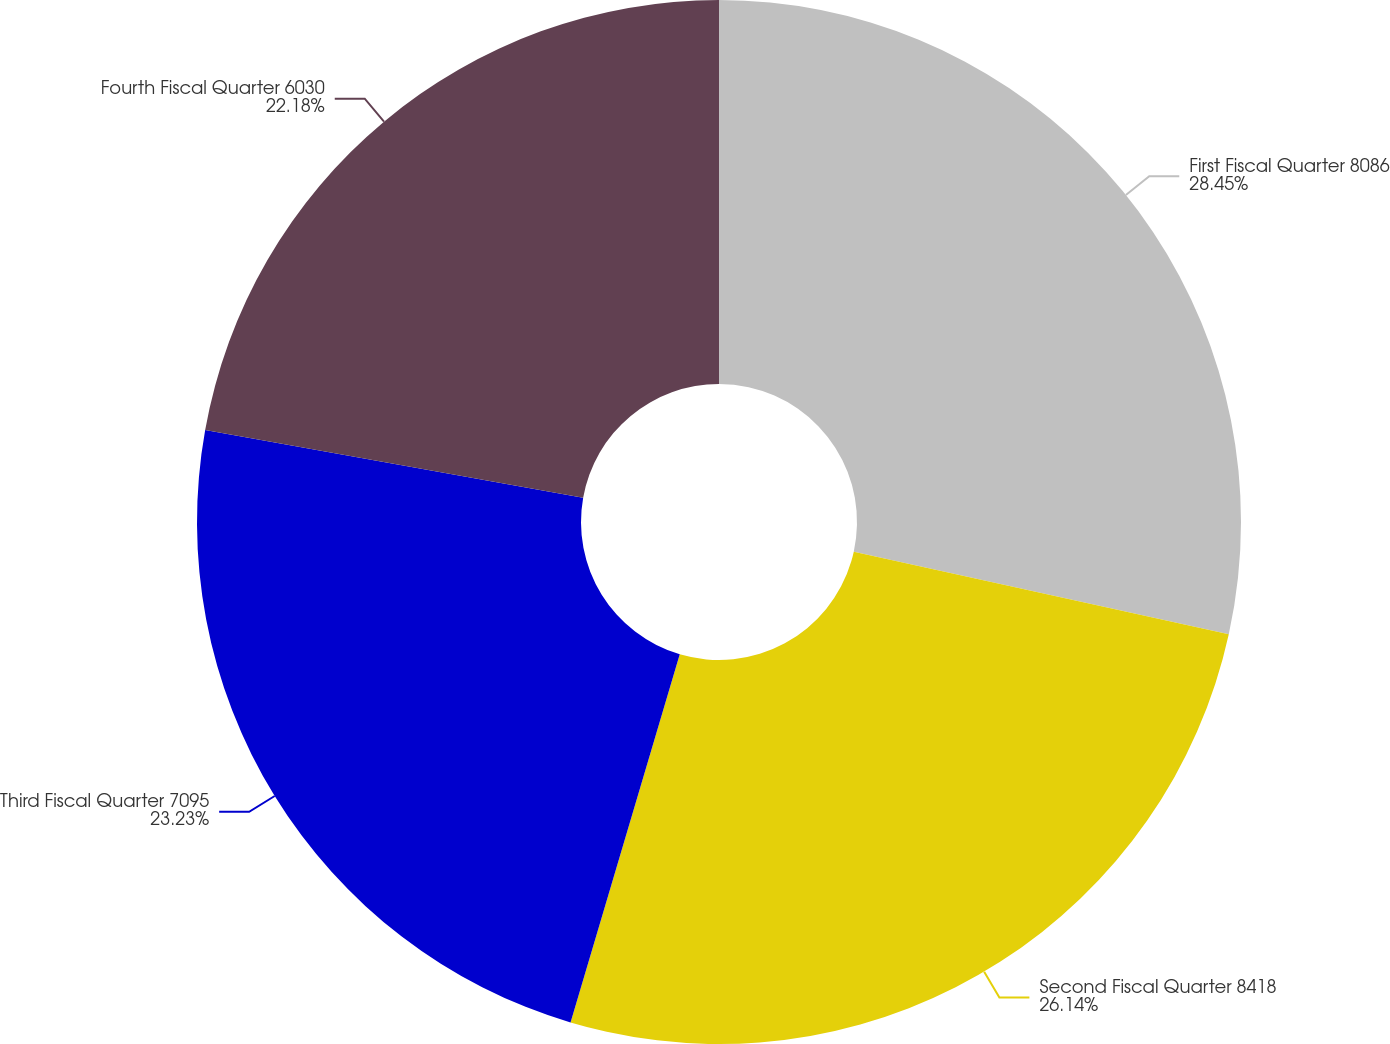<chart> <loc_0><loc_0><loc_500><loc_500><pie_chart><fcel>First Fiscal Quarter 8086<fcel>Second Fiscal Quarter 8418<fcel>Third Fiscal Quarter 7095<fcel>Fourth Fiscal Quarter 6030<nl><fcel>28.45%<fcel>26.14%<fcel>23.23%<fcel>22.18%<nl></chart> 